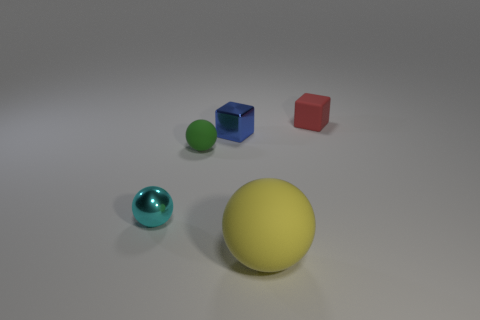Add 4 large green matte blocks. How many objects exist? 9 Subtract all cubes. How many objects are left? 3 Add 4 large yellow rubber objects. How many large yellow rubber objects exist? 5 Subtract 0 gray spheres. How many objects are left? 5 Subtract all small red matte things. Subtract all tiny blocks. How many objects are left? 2 Add 5 small green balls. How many small green balls are left? 6 